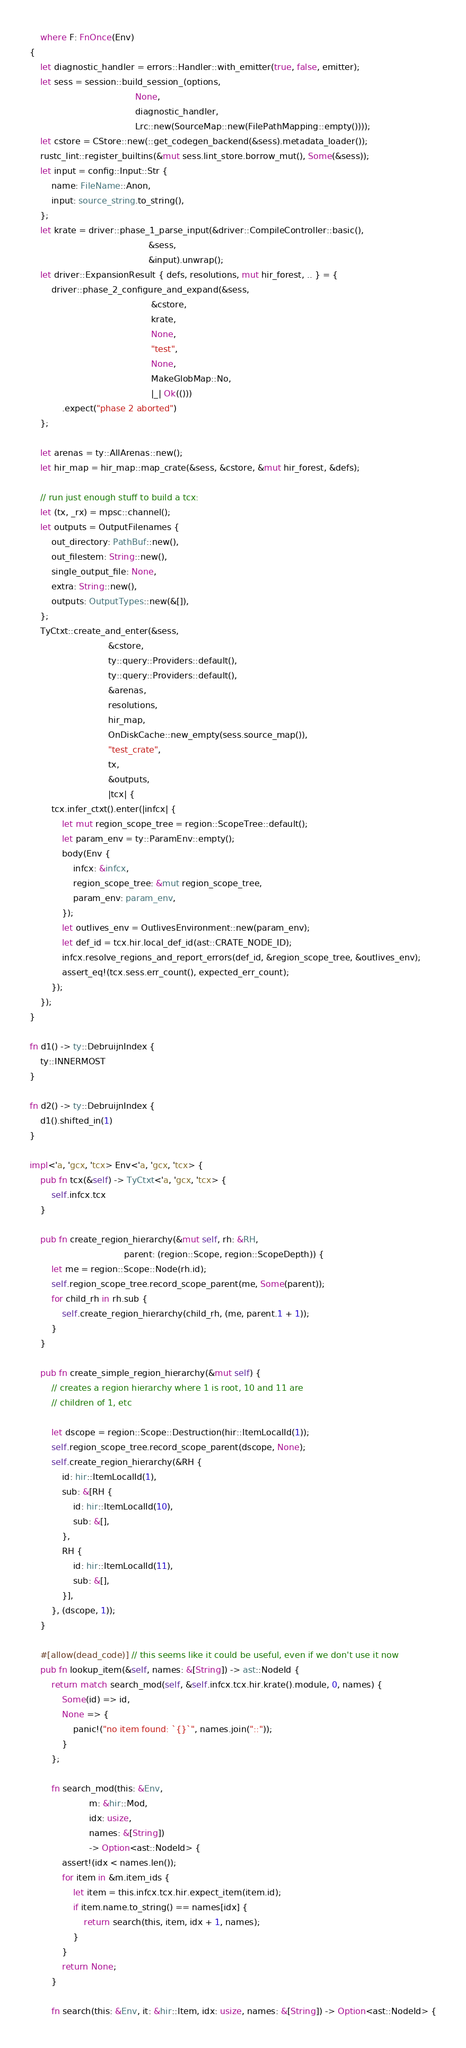Convert code to text. <code><loc_0><loc_0><loc_500><loc_500><_Rust_>    where F: FnOnce(Env)
{
    let diagnostic_handler = errors::Handler::with_emitter(true, false, emitter);
    let sess = session::build_session_(options,
                                       None,
                                       diagnostic_handler,
                                       Lrc::new(SourceMap::new(FilePathMapping::empty())));
    let cstore = CStore::new(::get_codegen_backend(&sess).metadata_loader());
    rustc_lint::register_builtins(&mut sess.lint_store.borrow_mut(), Some(&sess));
    let input = config::Input::Str {
        name: FileName::Anon,
        input: source_string.to_string(),
    };
    let krate = driver::phase_1_parse_input(&driver::CompileController::basic(),
                                            &sess,
                                            &input).unwrap();
    let driver::ExpansionResult { defs, resolutions, mut hir_forest, .. } = {
        driver::phase_2_configure_and_expand(&sess,
                                             &cstore,
                                             krate,
                                             None,
                                             "test",
                                             None,
                                             MakeGlobMap::No,
                                             |_| Ok(()))
            .expect("phase 2 aborted")
    };

    let arenas = ty::AllArenas::new();
    let hir_map = hir_map::map_crate(&sess, &cstore, &mut hir_forest, &defs);

    // run just enough stuff to build a tcx:
    let (tx, _rx) = mpsc::channel();
    let outputs = OutputFilenames {
        out_directory: PathBuf::new(),
        out_filestem: String::new(),
        single_output_file: None,
        extra: String::new(),
        outputs: OutputTypes::new(&[]),
    };
    TyCtxt::create_and_enter(&sess,
                             &cstore,
                             ty::query::Providers::default(),
                             ty::query::Providers::default(),
                             &arenas,
                             resolutions,
                             hir_map,
                             OnDiskCache::new_empty(sess.source_map()),
                             "test_crate",
                             tx,
                             &outputs,
                             |tcx| {
        tcx.infer_ctxt().enter(|infcx| {
            let mut region_scope_tree = region::ScopeTree::default();
            let param_env = ty::ParamEnv::empty();
            body(Env {
                infcx: &infcx,
                region_scope_tree: &mut region_scope_tree,
                param_env: param_env,
            });
            let outlives_env = OutlivesEnvironment::new(param_env);
            let def_id = tcx.hir.local_def_id(ast::CRATE_NODE_ID);
            infcx.resolve_regions_and_report_errors(def_id, &region_scope_tree, &outlives_env);
            assert_eq!(tcx.sess.err_count(), expected_err_count);
        });
    });
}

fn d1() -> ty::DebruijnIndex {
    ty::INNERMOST
}

fn d2() -> ty::DebruijnIndex {
    d1().shifted_in(1)
}

impl<'a, 'gcx, 'tcx> Env<'a, 'gcx, 'tcx> {
    pub fn tcx(&self) -> TyCtxt<'a, 'gcx, 'tcx> {
        self.infcx.tcx
    }

    pub fn create_region_hierarchy(&mut self, rh: &RH,
                                   parent: (region::Scope, region::ScopeDepth)) {
        let me = region::Scope::Node(rh.id);
        self.region_scope_tree.record_scope_parent(me, Some(parent));
        for child_rh in rh.sub {
            self.create_region_hierarchy(child_rh, (me, parent.1 + 1));
        }
    }

    pub fn create_simple_region_hierarchy(&mut self) {
        // creates a region hierarchy where 1 is root, 10 and 11 are
        // children of 1, etc

        let dscope = region::Scope::Destruction(hir::ItemLocalId(1));
        self.region_scope_tree.record_scope_parent(dscope, None);
        self.create_region_hierarchy(&RH {
            id: hir::ItemLocalId(1),
            sub: &[RH {
                id: hir::ItemLocalId(10),
                sub: &[],
            },
            RH {
                id: hir::ItemLocalId(11),
                sub: &[],
            }],
        }, (dscope, 1));
    }

    #[allow(dead_code)] // this seems like it could be useful, even if we don't use it now
    pub fn lookup_item(&self, names: &[String]) -> ast::NodeId {
        return match search_mod(self, &self.infcx.tcx.hir.krate().module, 0, names) {
            Some(id) => id,
            None => {
                panic!("no item found: `{}`", names.join("::"));
            }
        };

        fn search_mod(this: &Env,
                      m: &hir::Mod,
                      idx: usize,
                      names: &[String])
                      -> Option<ast::NodeId> {
            assert!(idx < names.len());
            for item in &m.item_ids {
                let item = this.infcx.tcx.hir.expect_item(item.id);
                if item.name.to_string() == names[idx] {
                    return search(this, item, idx + 1, names);
                }
            }
            return None;
        }

        fn search(this: &Env, it: &hir::Item, idx: usize, names: &[String]) -> Option<ast::NodeId> {</code> 